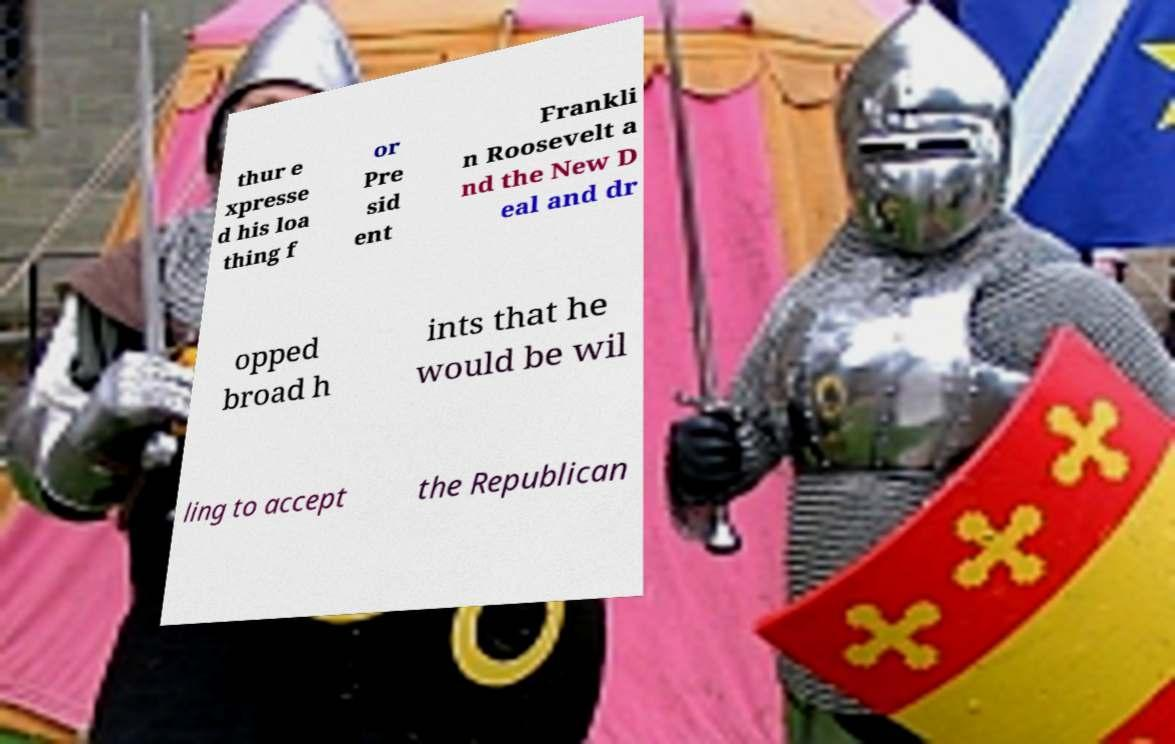There's text embedded in this image that I need extracted. Can you transcribe it verbatim? thur e xpresse d his loa thing f or Pre sid ent Frankli n Roosevelt a nd the New D eal and dr opped broad h ints that he would be wil ling to accept the Republican 